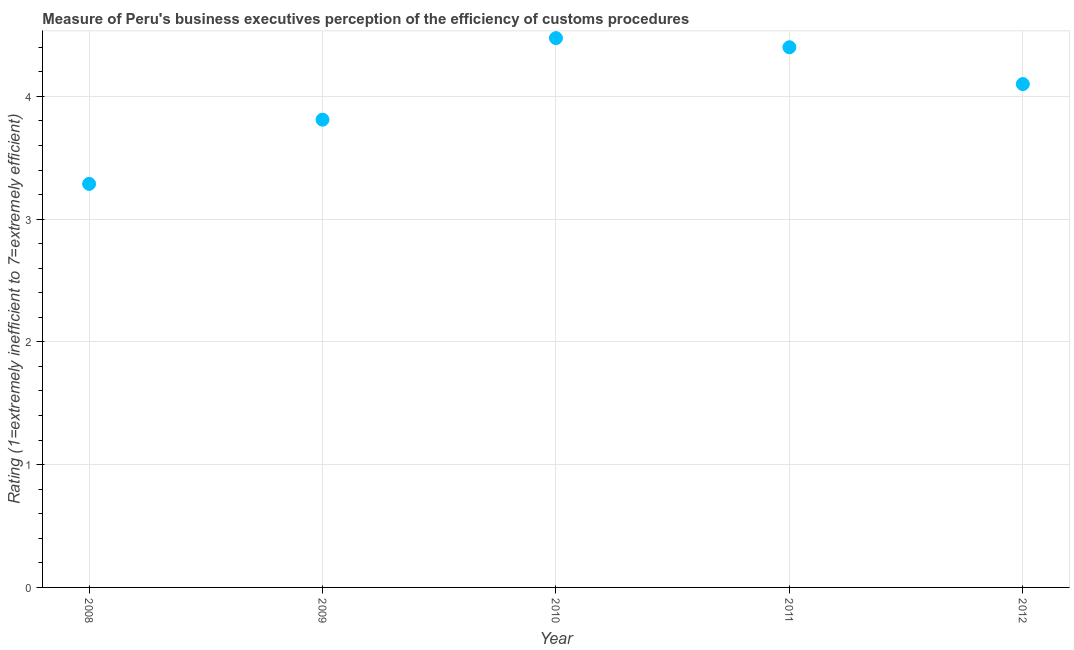What is the rating measuring burden of customs procedure in 2008?
Keep it short and to the point. 3.29. Across all years, what is the maximum rating measuring burden of customs procedure?
Provide a succinct answer. 4.47. Across all years, what is the minimum rating measuring burden of customs procedure?
Your response must be concise. 3.29. In which year was the rating measuring burden of customs procedure maximum?
Keep it short and to the point. 2010. In which year was the rating measuring burden of customs procedure minimum?
Keep it short and to the point. 2008. What is the sum of the rating measuring burden of customs procedure?
Ensure brevity in your answer.  20.07. What is the difference between the rating measuring burden of customs procedure in 2009 and 2012?
Your response must be concise. -0.29. What is the average rating measuring burden of customs procedure per year?
Offer a terse response. 4.01. Do a majority of the years between 2011 and 2012 (inclusive) have rating measuring burden of customs procedure greater than 1.8 ?
Provide a succinct answer. Yes. What is the ratio of the rating measuring burden of customs procedure in 2008 to that in 2010?
Keep it short and to the point. 0.73. Is the rating measuring burden of customs procedure in 2009 less than that in 2011?
Ensure brevity in your answer.  Yes. Is the difference between the rating measuring burden of customs procedure in 2010 and 2011 greater than the difference between any two years?
Make the answer very short. No. What is the difference between the highest and the second highest rating measuring burden of customs procedure?
Make the answer very short. 0.07. What is the difference between the highest and the lowest rating measuring burden of customs procedure?
Give a very brief answer. 1.19. In how many years, is the rating measuring burden of customs procedure greater than the average rating measuring burden of customs procedure taken over all years?
Provide a short and direct response. 3. Does the graph contain any zero values?
Give a very brief answer. No. What is the title of the graph?
Provide a succinct answer. Measure of Peru's business executives perception of the efficiency of customs procedures. What is the label or title of the X-axis?
Your response must be concise. Year. What is the label or title of the Y-axis?
Offer a terse response. Rating (1=extremely inefficient to 7=extremely efficient). What is the Rating (1=extremely inefficient to 7=extremely efficient) in 2008?
Offer a very short reply. 3.29. What is the Rating (1=extremely inefficient to 7=extremely efficient) in 2009?
Keep it short and to the point. 3.81. What is the Rating (1=extremely inefficient to 7=extremely efficient) in 2010?
Make the answer very short. 4.47. What is the difference between the Rating (1=extremely inefficient to 7=extremely efficient) in 2008 and 2009?
Give a very brief answer. -0.52. What is the difference between the Rating (1=extremely inefficient to 7=extremely efficient) in 2008 and 2010?
Your answer should be very brief. -1.19. What is the difference between the Rating (1=extremely inefficient to 7=extremely efficient) in 2008 and 2011?
Make the answer very short. -1.11. What is the difference between the Rating (1=extremely inefficient to 7=extremely efficient) in 2008 and 2012?
Keep it short and to the point. -0.81. What is the difference between the Rating (1=extremely inefficient to 7=extremely efficient) in 2009 and 2010?
Offer a very short reply. -0.66. What is the difference between the Rating (1=extremely inefficient to 7=extremely efficient) in 2009 and 2011?
Ensure brevity in your answer.  -0.59. What is the difference between the Rating (1=extremely inefficient to 7=extremely efficient) in 2009 and 2012?
Provide a succinct answer. -0.29. What is the difference between the Rating (1=extremely inefficient to 7=extremely efficient) in 2010 and 2011?
Your response must be concise. 0.07. What is the difference between the Rating (1=extremely inefficient to 7=extremely efficient) in 2010 and 2012?
Ensure brevity in your answer.  0.37. What is the difference between the Rating (1=extremely inefficient to 7=extremely efficient) in 2011 and 2012?
Offer a terse response. 0.3. What is the ratio of the Rating (1=extremely inefficient to 7=extremely efficient) in 2008 to that in 2009?
Make the answer very short. 0.86. What is the ratio of the Rating (1=extremely inefficient to 7=extremely efficient) in 2008 to that in 2010?
Offer a very short reply. 0.73. What is the ratio of the Rating (1=extremely inefficient to 7=extremely efficient) in 2008 to that in 2011?
Give a very brief answer. 0.75. What is the ratio of the Rating (1=extremely inefficient to 7=extremely efficient) in 2008 to that in 2012?
Provide a short and direct response. 0.8. What is the ratio of the Rating (1=extremely inefficient to 7=extremely efficient) in 2009 to that in 2010?
Your answer should be very brief. 0.85. What is the ratio of the Rating (1=extremely inefficient to 7=extremely efficient) in 2009 to that in 2011?
Ensure brevity in your answer.  0.87. What is the ratio of the Rating (1=extremely inefficient to 7=extremely efficient) in 2009 to that in 2012?
Your answer should be very brief. 0.93. What is the ratio of the Rating (1=extremely inefficient to 7=extremely efficient) in 2010 to that in 2012?
Your answer should be very brief. 1.09. What is the ratio of the Rating (1=extremely inefficient to 7=extremely efficient) in 2011 to that in 2012?
Your response must be concise. 1.07. 